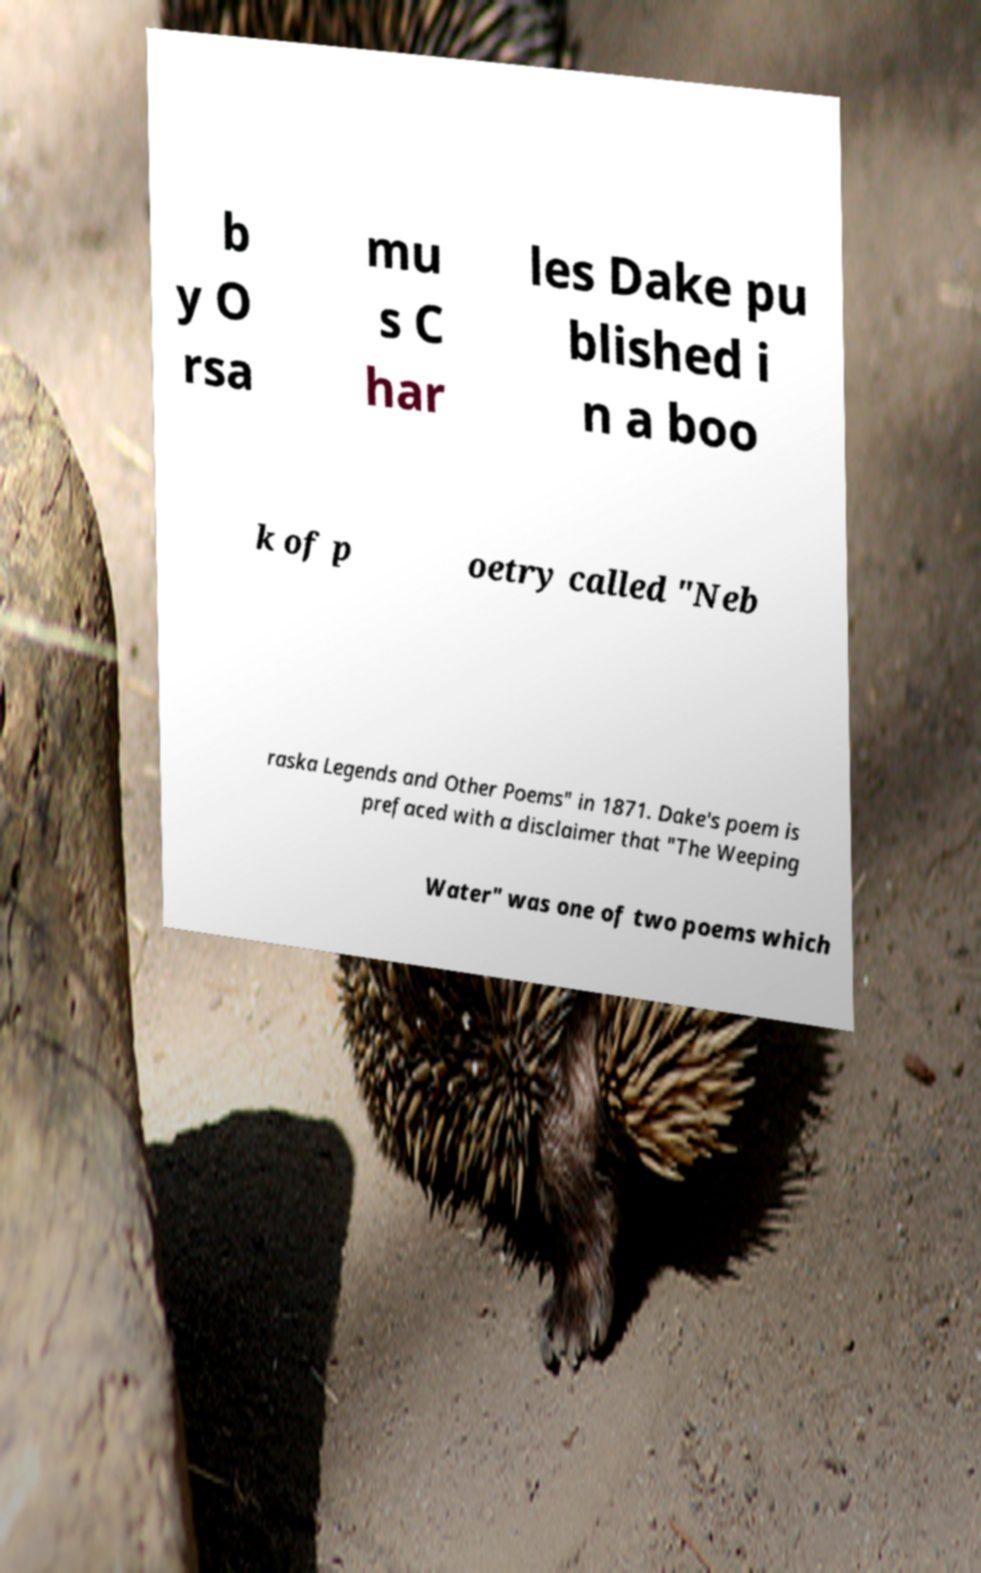There's text embedded in this image that I need extracted. Can you transcribe it verbatim? b y O rsa mu s C har les Dake pu blished i n a boo k of p oetry called "Neb raska Legends and Other Poems" in 1871. Dake's poem is prefaced with a disclaimer that "The Weeping Water" was one of two poems which 